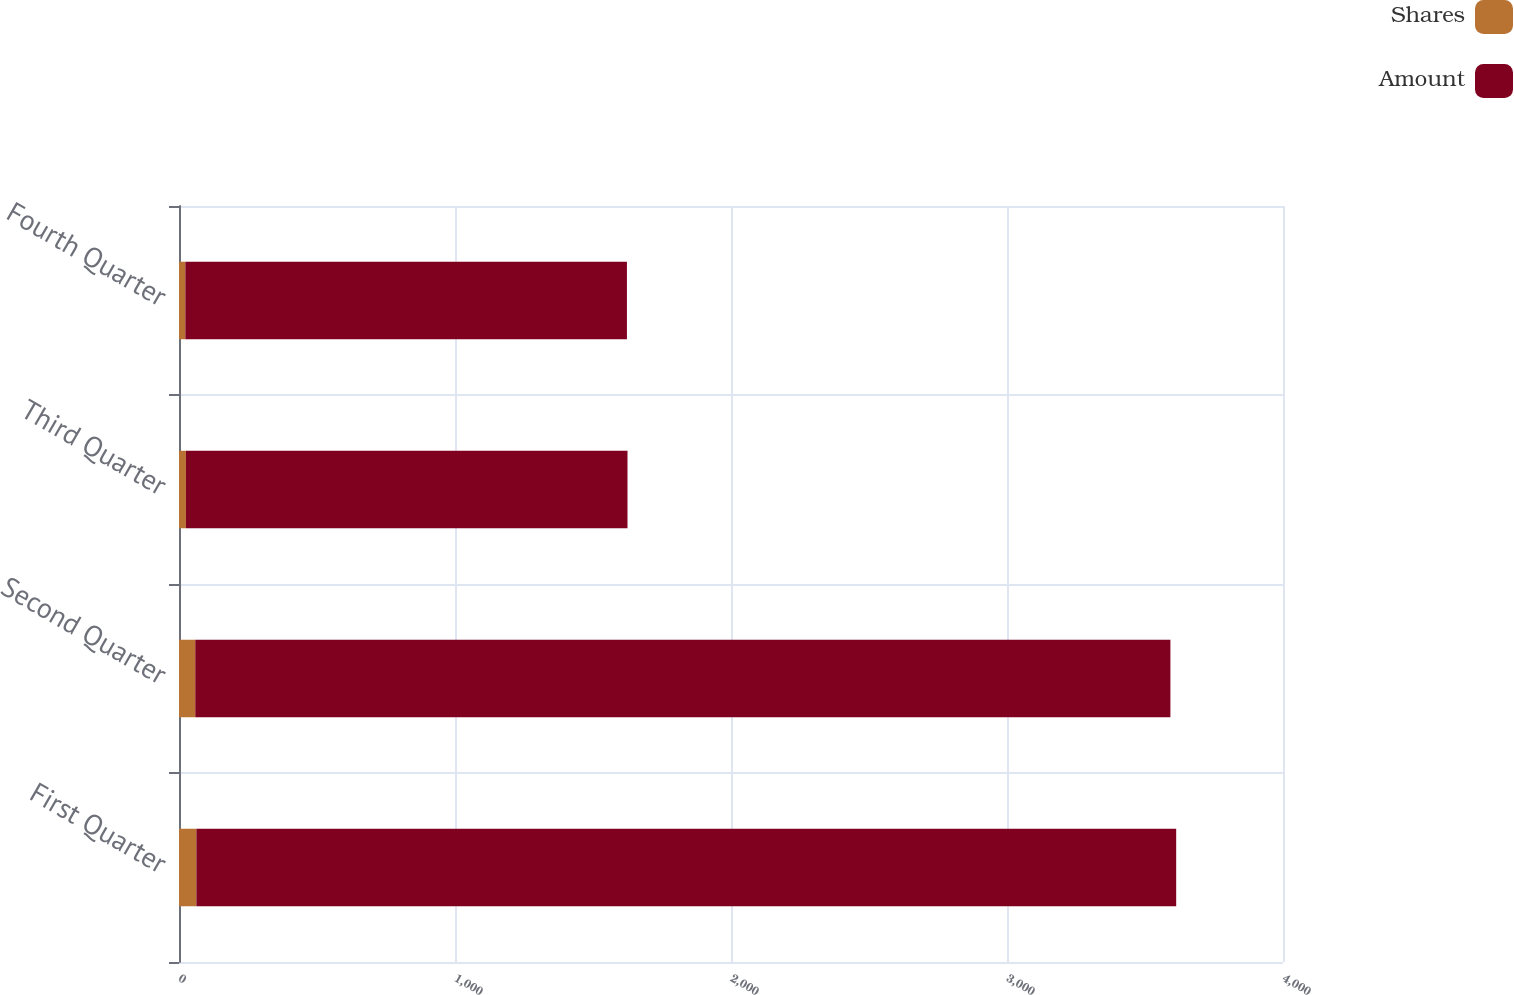<chart> <loc_0><loc_0><loc_500><loc_500><stacked_bar_chart><ecel><fcel>First Quarter<fcel>Second Quarter<fcel>Third Quarter<fcel>Fourth Quarter<nl><fcel>Shares<fcel>63<fcel>59<fcel>25<fcel>23<nl><fcel>Amount<fcel>3550<fcel>3533<fcel>1600<fcel>1600<nl></chart> 